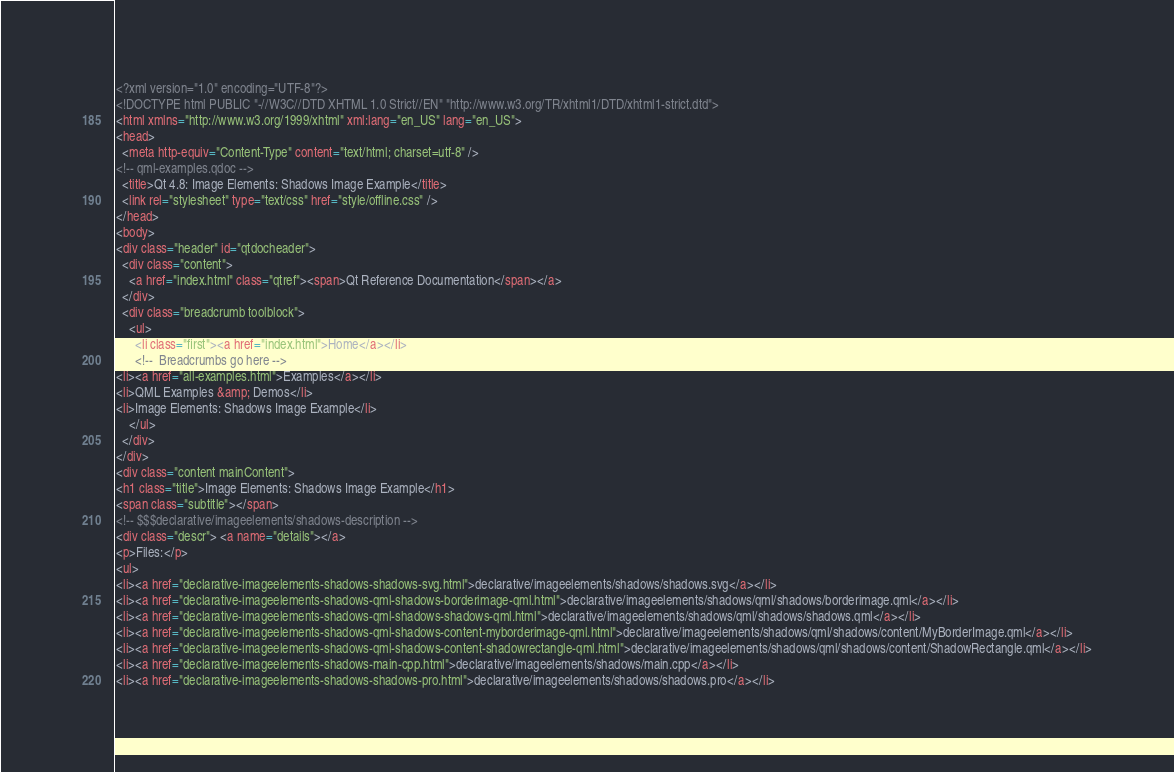Convert code to text. <code><loc_0><loc_0><loc_500><loc_500><_HTML_><?xml version="1.0" encoding="UTF-8"?>
<!DOCTYPE html PUBLIC "-//W3C//DTD XHTML 1.0 Strict//EN" "http://www.w3.org/TR/xhtml1/DTD/xhtml1-strict.dtd">
<html xmlns="http://www.w3.org/1999/xhtml" xml:lang="en_US" lang="en_US">
<head>
  <meta http-equiv="Content-Type" content="text/html; charset=utf-8" />
<!-- qml-examples.qdoc -->
  <title>Qt 4.8: Image Elements: Shadows Image Example</title>
  <link rel="stylesheet" type="text/css" href="style/offline.css" />
</head>
<body>
<div class="header" id="qtdocheader">
  <div class="content"> 
    <a href="index.html" class="qtref"><span>Qt Reference Documentation</span></a>
  </div>
  <div class="breadcrumb toolblock">
    <ul>
      <li class="first"><a href="index.html">Home</a></li>
      <!--  Breadcrumbs go here -->
<li><a href="all-examples.html">Examples</a></li>
<li>QML Examples &amp; Demos</li>
<li>Image Elements: Shadows Image Example</li>
    </ul>
  </div>
</div>
<div class="content mainContent">
<h1 class="title">Image Elements: Shadows Image Example</h1>
<span class="subtitle"></span>
<!-- $$$declarative/imageelements/shadows-description -->
<div class="descr"> <a name="details"></a>
<p>Files:</p>
<ul>
<li><a href="declarative-imageelements-shadows-shadows-svg.html">declarative/imageelements/shadows/shadows.svg</a></li>
<li><a href="declarative-imageelements-shadows-qml-shadows-borderimage-qml.html">declarative/imageelements/shadows/qml/shadows/borderimage.qml</a></li>
<li><a href="declarative-imageelements-shadows-qml-shadows-shadows-qml.html">declarative/imageelements/shadows/qml/shadows/shadows.qml</a></li>
<li><a href="declarative-imageelements-shadows-qml-shadows-content-myborderimage-qml.html">declarative/imageelements/shadows/qml/shadows/content/MyBorderImage.qml</a></li>
<li><a href="declarative-imageelements-shadows-qml-shadows-content-shadowrectangle-qml.html">declarative/imageelements/shadows/qml/shadows/content/ShadowRectangle.qml</a></li>
<li><a href="declarative-imageelements-shadows-main-cpp.html">declarative/imageelements/shadows/main.cpp</a></li>
<li><a href="declarative-imageelements-shadows-shadows-pro.html">declarative/imageelements/shadows/shadows.pro</a></li></code> 